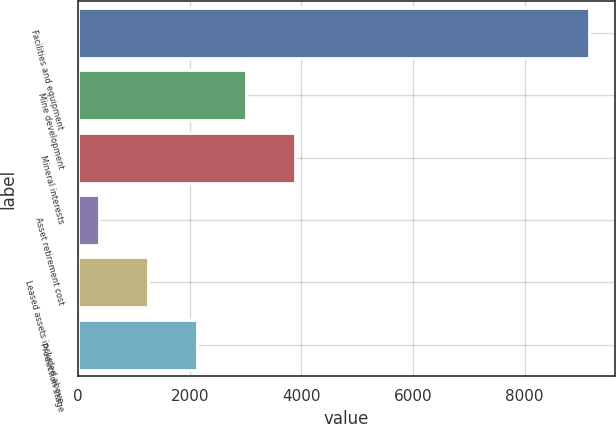Convert chart to OTSL. <chart><loc_0><loc_0><loc_500><loc_500><bar_chart><fcel>Facilities and equipment<fcel>Mine development<fcel>Mineral interests<fcel>Asset retirement cost<fcel>Leased assets included above<fcel>Production stage<nl><fcel>9158<fcel>3016.2<fcel>3893.6<fcel>384<fcel>1261.4<fcel>2138.8<nl></chart> 